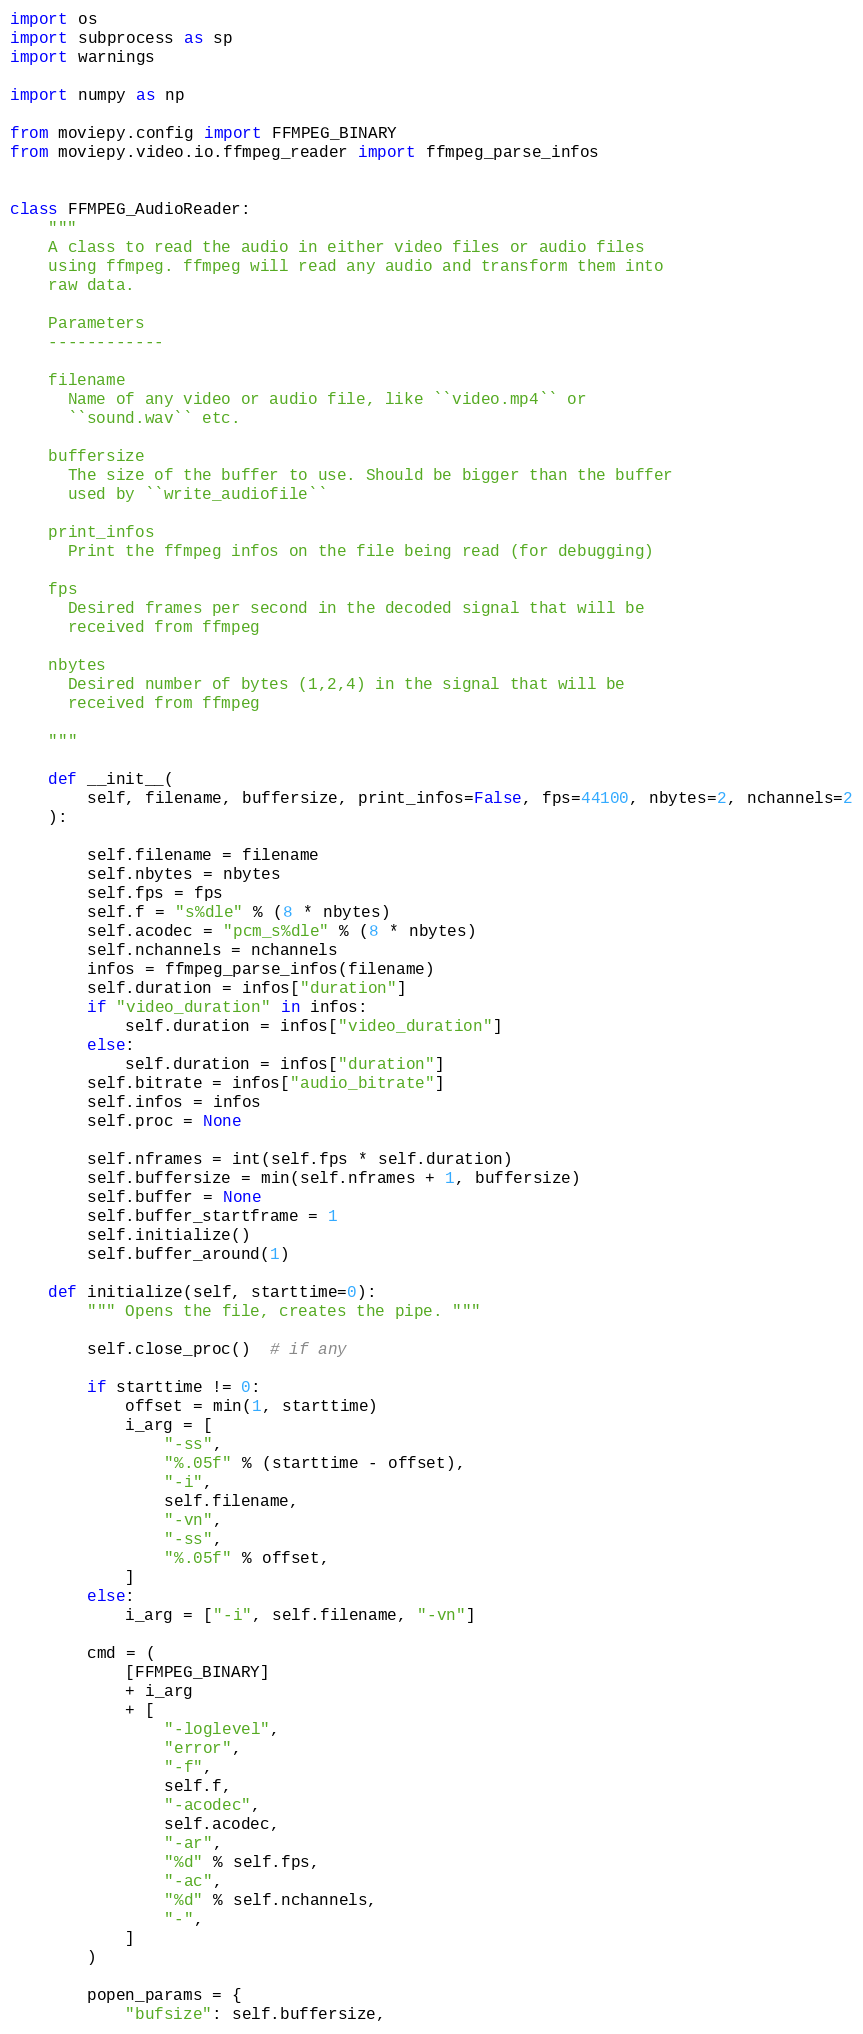Convert code to text. <code><loc_0><loc_0><loc_500><loc_500><_Python_>import os
import subprocess as sp
import warnings

import numpy as np

from moviepy.config import FFMPEG_BINARY
from moviepy.video.io.ffmpeg_reader import ffmpeg_parse_infos


class FFMPEG_AudioReader:
    """
    A class to read the audio in either video files or audio files
    using ffmpeg. ffmpeg will read any audio and transform them into
    raw data.

    Parameters
    ------------

    filename
      Name of any video or audio file, like ``video.mp4`` or
      ``sound.wav`` etc.

    buffersize
      The size of the buffer to use. Should be bigger than the buffer
      used by ``write_audiofile``

    print_infos
      Print the ffmpeg infos on the file being read (for debugging)

    fps
      Desired frames per second in the decoded signal that will be
      received from ffmpeg

    nbytes
      Desired number of bytes (1,2,4) in the signal that will be
      received from ffmpeg

    """

    def __init__(
        self, filename, buffersize, print_infos=False, fps=44100, nbytes=2, nchannels=2
    ):

        self.filename = filename
        self.nbytes = nbytes
        self.fps = fps
        self.f = "s%dle" % (8 * nbytes)
        self.acodec = "pcm_s%dle" % (8 * nbytes)
        self.nchannels = nchannels
        infos = ffmpeg_parse_infos(filename)
        self.duration = infos["duration"]
        if "video_duration" in infos:
            self.duration = infos["video_duration"]
        else:
            self.duration = infos["duration"]
        self.bitrate = infos["audio_bitrate"]
        self.infos = infos
        self.proc = None

        self.nframes = int(self.fps * self.duration)
        self.buffersize = min(self.nframes + 1, buffersize)
        self.buffer = None
        self.buffer_startframe = 1
        self.initialize()
        self.buffer_around(1)

    def initialize(self, starttime=0):
        """ Opens the file, creates the pipe. """

        self.close_proc()  # if any

        if starttime != 0:
            offset = min(1, starttime)
            i_arg = [
                "-ss",
                "%.05f" % (starttime - offset),
                "-i",
                self.filename,
                "-vn",
                "-ss",
                "%.05f" % offset,
            ]
        else:
            i_arg = ["-i", self.filename, "-vn"]

        cmd = (
            [FFMPEG_BINARY]
            + i_arg
            + [
                "-loglevel",
                "error",
                "-f",
                self.f,
                "-acodec",
                self.acodec,
                "-ar",
                "%d" % self.fps,
                "-ac",
                "%d" % self.nchannels,
                "-",
            ]
        )

        popen_params = {
            "bufsize": self.buffersize,</code> 